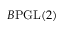<formula> <loc_0><loc_0><loc_500><loc_500>B { P G L } ( 2 )</formula> 